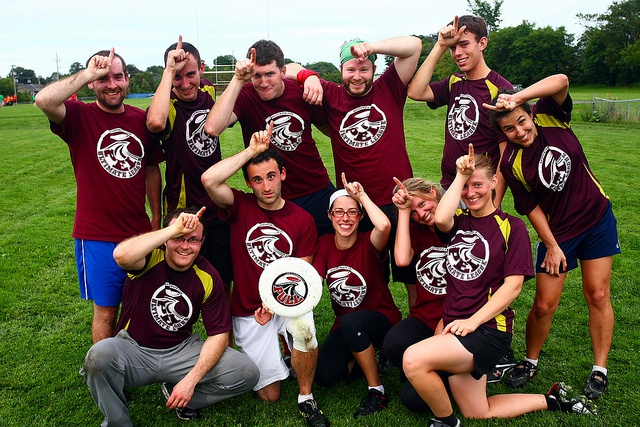Describe the objects in this image and their specific colors. I can see people in white, black, maroon, and salmon tones, people in white, black, gray, darkgray, and maroon tones, people in white, lightgray, maroon, black, and darkgray tones, people in white, black, maroon, brown, and red tones, and people in white, maroon, black, darkblue, and lightgray tones in this image. 